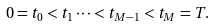<formula> <loc_0><loc_0><loc_500><loc_500>0 = t _ { 0 } < t _ { 1 } \cdots < t _ { M - 1 } < t _ { M } = T .</formula> 